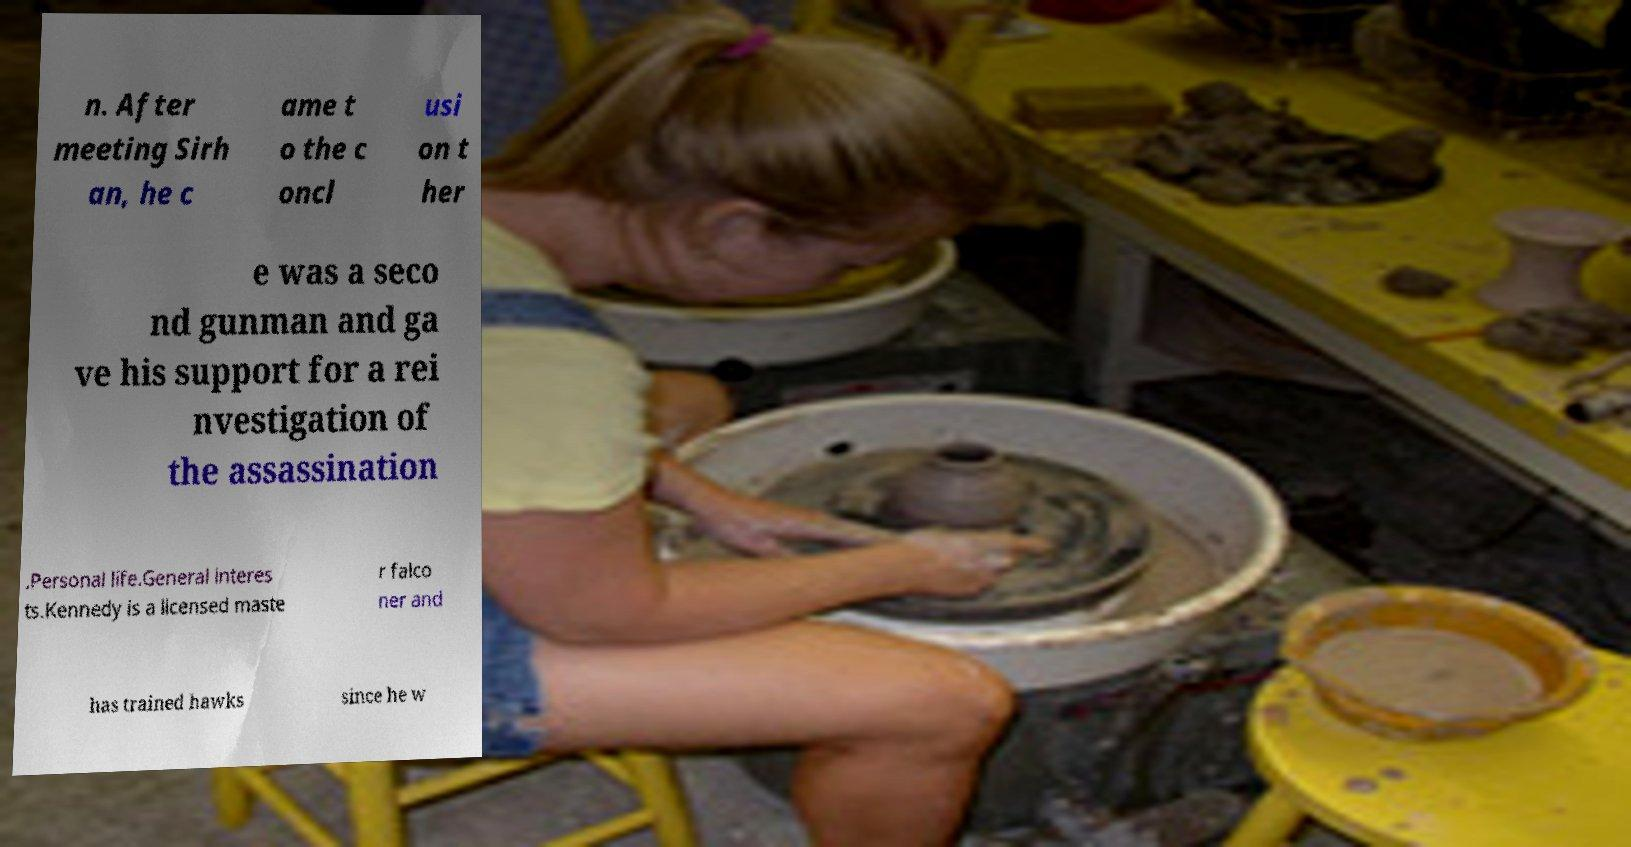Could you assist in decoding the text presented in this image and type it out clearly? n. After meeting Sirh an, he c ame t o the c oncl usi on t her e was a seco nd gunman and ga ve his support for a rei nvestigation of the assassination .Personal life.General interes ts.Kennedy is a licensed maste r falco ner and has trained hawks since he w 